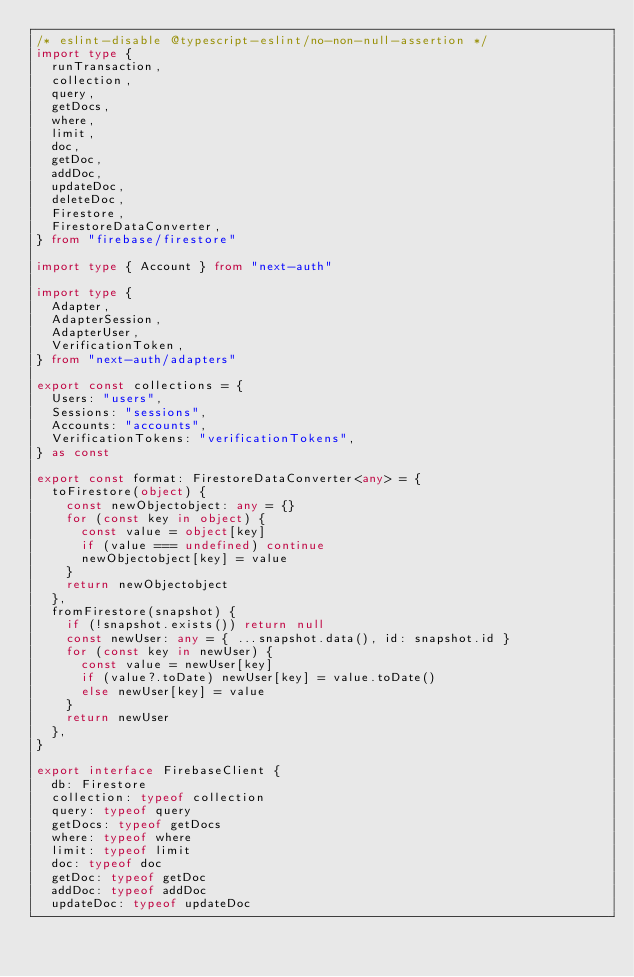Convert code to text. <code><loc_0><loc_0><loc_500><loc_500><_TypeScript_>/* eslint-disable @typescript-eslint/no-non-null-assertion */
import type {
  runTransaction,
  collection,
  query,
  getDocs,
  where,
  limit,
  doc,
  getDoc,
  addDoc,
  updateDoc,
  deleteDoc,
  Firestore,
  FirestoreDataConverter,
} from "firebase/firestore"

import type { Account } from "next-auth"

import type {
  Adapter,
  AdapterSession,
  AdapterUser,
  VerificationToken,
} from "next-auth/adapters"

export const collections = {
  Users: "users",
  Sessions: "sessions",
  Accounts: "accounts",
  VerificationTokens: "verificationTokens",
} as const

export const format: FirestoreDataConverter<any> = {
  toFirestore(object) {
    const newObjectobject: any = {}
    for (const key in object) {
      const value = object[key]
      if (value === undefined) continue
      newObjectobject[key] = value
    }
    return newObjectobject
  },
  fromFirestore(snapshot) {
    if (!snapshot.exists()) return null
    const newUser: any = { ...snapshot.data(), id: snapshot.id }
    for (const key in newUser) {
      const value = newUser[key]
      if (value?.toDate) newUser[key] = value.toDate()
      else newUser[key] = value
    }
    return newUser
  },
}

export interface FirebaseClient {
  db: Firestore
  collection: typeof collection
  query: typeof query
  getDocs: typeof getDocs
  where: typeof where
  limit: typeof limit
  doc: typeof doc
  getDoc: typeof getDoc
  addDoc: typeof addDoc
  updateDoc: typeof updateDoc</code> 